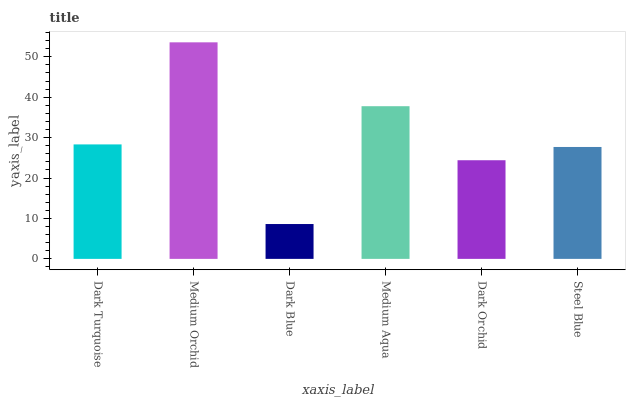Is Dark Blue the minimum?
Answer yes or no. Yes. Is Medium Orchid the maximum?
Answer yes or no. Yes. Is Medium Orchid the minimum?
Answer yes or no. No. Is Dark Blue the maximum?
Answer yes or no. No. Is Medium Orchid greater than Dark Blue?
Answer yes or no. Yes. Is Dark Blue less than Medium Orchid?
Answer yes or no. Yes. Is Dark Blue greater than Medium Orchid?
Answer yes or no. No. Is Medium Orchid less than Dark Blue?
Answer yes or no. No. Is Dark Turquoise the high median?
Answer yes or no. Yes. Is Steel Blue the low median?
Answer yes or no. Yes. Is Medium Orchid the high median?
Answer yes or no. No. Is Medium Orchid the low median?
Answer yes or no. No. 